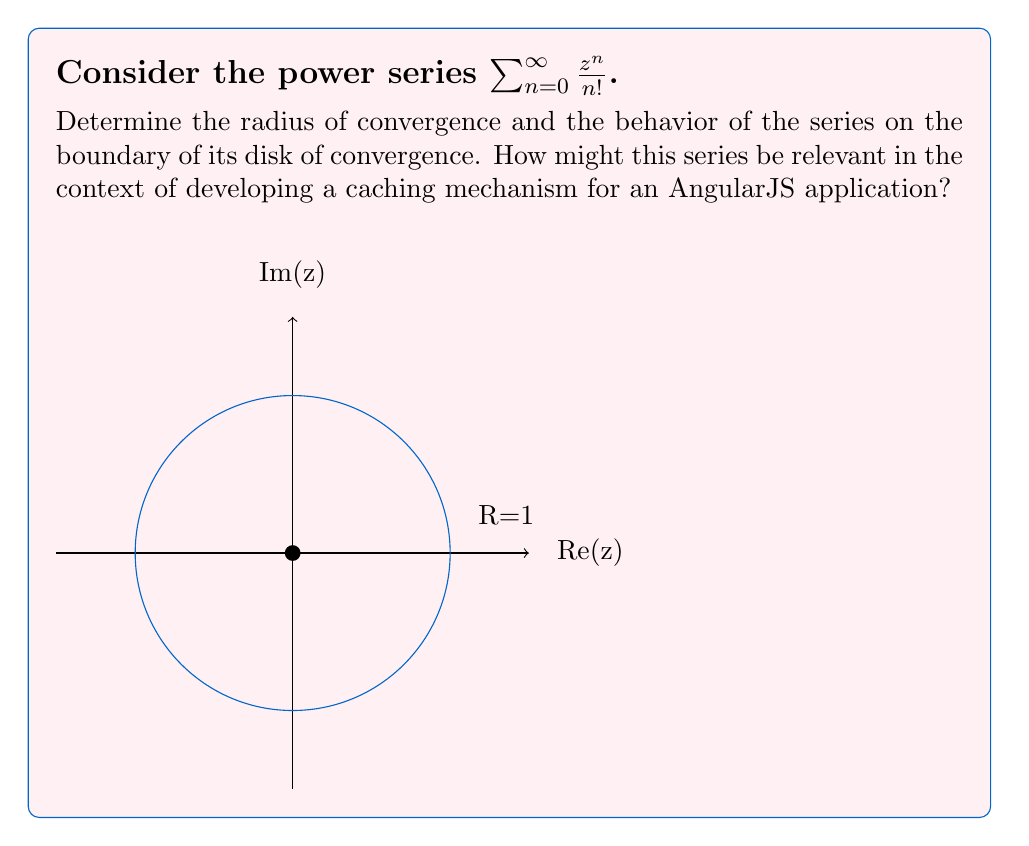Can you solve this math problem? Let's approach this step-by-step:

1) To find the radius of convergence, we can use the ratio test:

   $$\lim_{n \to \infty} \left|\frac{a_{n+1}}{a_n}\right| = \lim_{n \to \infty} \left|\frac{z^{n+1}/(n+1)!}{z^n/n!}\right| = \lim_{n \to \infty} \left|\frac{z}{n+1}\right| = 0$$

2) Since this limit is 0 for any finite z, the radius of convergence R is infinite. The series converges for all complex numbers.

3) As the radius of convergence is infinite, there is no boundary of convergence to consider.

4) This series is actually the Taylor series for $e^z$, which converges everywhere in the complex plane.

5) In the context of AngularJS development, this series could be relevant for implementing an exponential backoff algorithm in a caching mechanism. For example:

   - When a cache miss occurs, you might want to wait before trying to fetch the data again.
   - The wait time could be calculated using this series, with z being the number of attempts.
   - This would result in increasingly longer wait times between attempts, following an exponential pattern.

6) The infinite radius of convergence ensures that this approach would work for any number of retry attempts, providing a robust and scalable solution for cache management in a distributed AngularJS application.
Answer: Radius of convergence: $R = \infty$. The series converges for all complex numbers. 